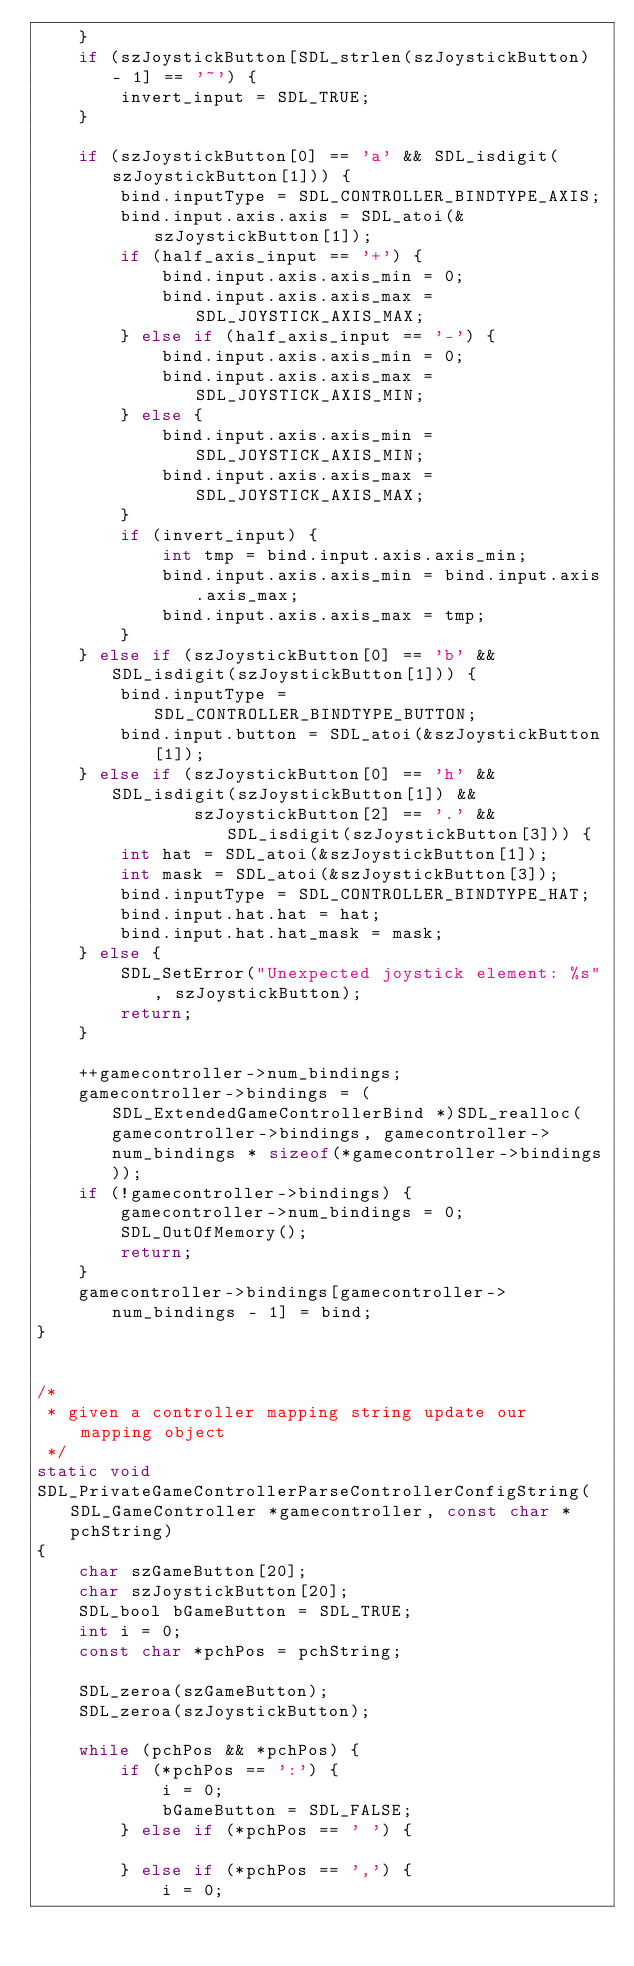<code> <loc_0><loc_0><loc_500><loc_500><_C_>    }
    if (szJoystickButton[SDL_strlen(szJoystickButton) - 1] == '~') {
        invert_input = SDL_TRUE;
    }

    if (szJoystickButton[0] == 'a' && SDL_isdigit(szJoystickButton[1])) {
        bind.inputType = SDL_CONTROLLER_BINDTYPE_AXIS;
        bind.input.axis.axis = SDL_atoi(&szJoystickButton[1]);
        if (half_axis_input == '+') {
            bind.input.axis.axis_min = 0;
            bind.input.axis.axis_max = SDL_JOYSTICK_AXIS_MAX;
        } else if (half_axis_input == '-') {
            bind.input.axis.axis_min = 0;
            bind.input.axis.axis_max = SDL_JOYSTICK_AXIS_MIN;
        } else {
            bind.input.axis.axis_min = SDL_JOYSTICK_AXIS_MIN;
            bind.input.axis.axis_max = SDL_JOYSTICK_AXIS_MAX;
        }
        if (invert_input) {
            int tmp = bind.input.axis.axis_min;
            bind.input.axis.axis_min = bind.input.axis.axis_max;
            bind.input.axis.axis_max = tmp;
        }
    } else if (szJoystickButton[0] == 'b' && SDL_isdigit(szJoystickButton[1])) {
        bind.inputType = SDL_CONTROLLER_BINDTYPE_BUTTON;
        bind.input.button = SDL_atoi(&szJoystickButton[1]);
    } else if (szJoystickButton[0] == 'h' && SDL_isdigit(szJoystickButton[1]) &&
               szJoystickButton[2] == '.' && SDL_isdigit(szJoystickButton[3])) {
        int hat = SDL_atoi(&szJoystickButton[1]);
        int mask = SDL_atoi(&szJoystickButton[3]);
        bind.inputType = SDL_CONTROLLER_BINDTYPE_HAT;
        bind.input.hat.hat = hat;
        bind.input.hat.hat_mask = mask;
    } else {
        SDL_SetError("Unexpected joystick element: %s", szJoystickButton);
        return;
    }

    ++gamecontroller->num_bindings;
    gamecontroller->bindings = (SDL_ExtendedGameControllerBind *)SDL_realloc(gamecontroller->bindings, gamecontroller->num_bindings * sizeof(*gamecontroller->bindings));
    if (!gamecontroller->bindings) {
        gamecontroller->num_bindings = 0;
        SDL_OutOfMemory();
        return;
    }
    gamecontroller->bindings[gamecontroller->num_bindings - 1] = bind;
}


/*
 * given a controller mapping string update our mapping object
 */
static void
SDL_PrivateGameControllerParseControllerConfigString(SDL_GameController *gamecontroller, const char *pchString)
{
    char szGameButton[20];
    char szJoystickButton[20];
    SDL_bool bGameButton = SDL_TRUE;
    int i = 0;
    const char *pchPos = pchString;

    SDL_zeroa(szGameButton);
    SDL_zeroa(szJoystickButton);

    while (pchPos && *pchPos) {
        if (*pchPos == ':') {
            i = 0;
            bGameButton = SDL_FALSE;
        } else if (*pchPos == ' ') {

        } else if (*pchPos == ',') {
            i = 0;</code> 